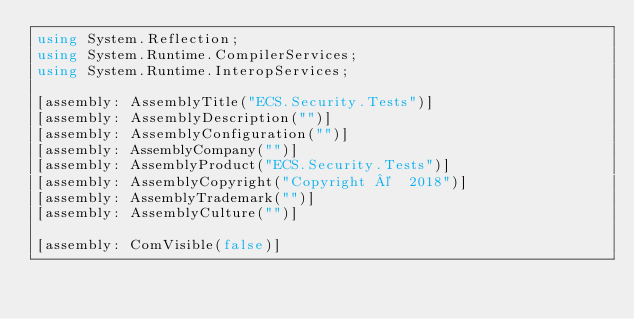<code> <loc_0><loc_0><loc_500><loc_500><_C#_>using System.Reflection;
using System.Runtime.CompilerServices;
using System.Runtime.InteropServices;

[assembly: AssemblyTitle("ECS.Security.Tests")]
[assembly: AssemblyDescription("")]
[assembly: AssemblyConfiguration("")]
[assembly: AssemblyCompany("")]
[assembly: AssemblyProduct("ECS.Security.Tests")]
[assembly: AssemblyCopyright("Copyright ©  2018")]
[assembly: AssemblyTrademark("")]
[assembly: AssemblyCulture("")]

[assembly: ComVisible(false)]
</code> 